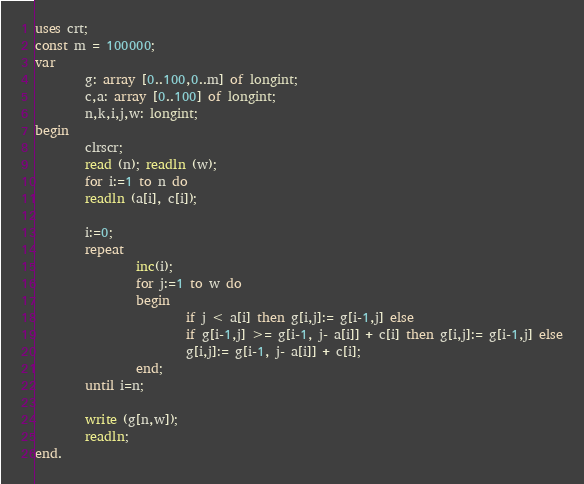Convert code to text. <code><loc_0><loc_0><loc_500><loc_500><_Pascal_>uses crt;
const m = 100000;
var
        g: array [0..100,0..m] of longint;
        c,a: array [0..100] of longint;
        n,k,i,j,w: longint;
begin
        clrscr;
        read (n); readln (w);
        for i:=1 to n do
        readln (a[i], c[i]);

        i:=0;
        repeat
                inc(i);
                for j:=1 to w do
                begin
                        if j < a[i] then g[i,j]:= g[i-1,j] else
                        if g[i-1,j] >= g[i-1, j- a[i]] + c[i] then g[i,j]:= g[i-1,j] else
                        g[i,j]:= g[i-1, j- a[i]] + c[i];
                end;
        until i=n;

        write (g[n,w]);
        readln;
end.</code> 